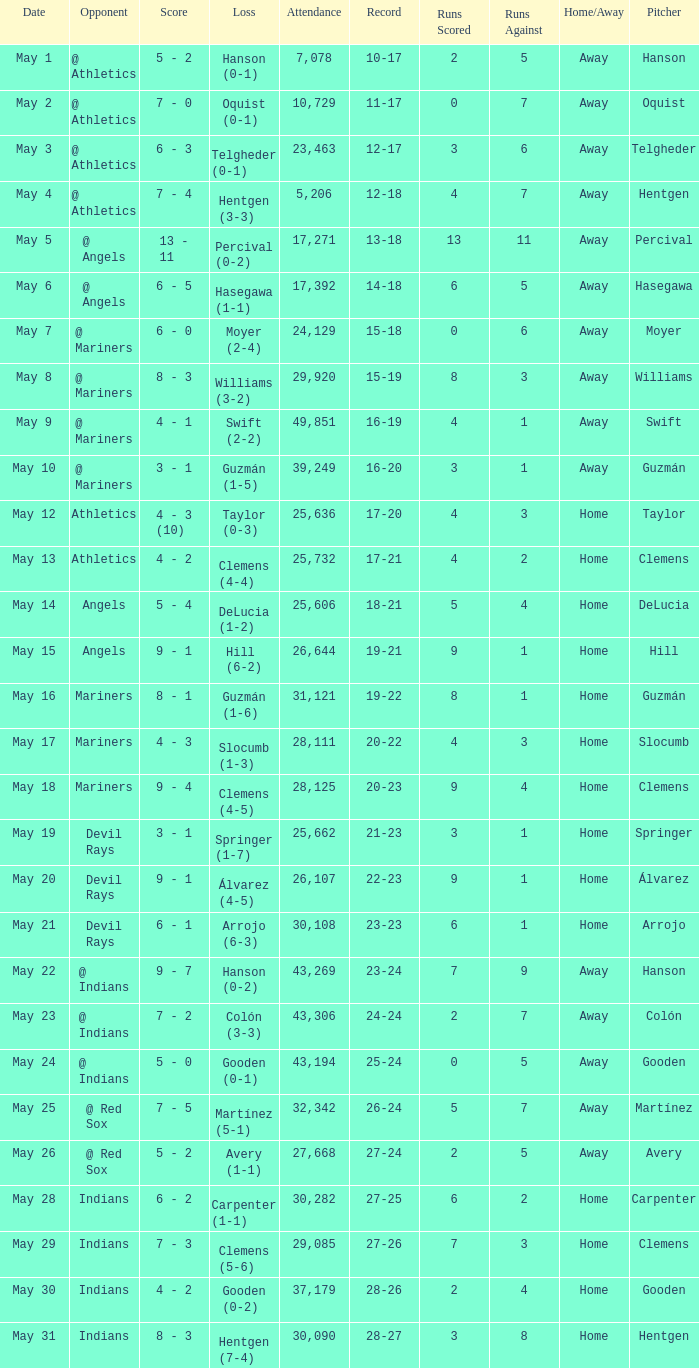Write the full table. {'header': ['Date', 'Opponent', 'Score', 'Loss', 'Attendance', 'Record', 'Runs Scored', 'Runs Against', 'Home/Away', 'Pitcher'], 'rows': [['May 1', '@ Athletics', '5 - 2', 'Hanson (0-1)', '7,078', '10-17', '2', '5', 'Away', 'Hanson'], ['May 2', '@ Athletics', '7 - 0', 'Oquist (0-1)', '10,729', '11-17', '0', '7', 'Away', 'Oquist'], ['May 3', '@ Athletics', '6 - 3', 'Telgheder (0-1)', '23,463', '12-17', '3', '6', 'Away', 'Telgheder'], ['May 4', '@ Athletics', '7 - 4', 'Hentgen (3-3)', '5,206', '12-18', '4', '7', 'Away', 'Hentgen'], ['May 5', '@ Angels', '13 - 11', 'Percival (0-2)', '17,271', '13-18', '13', '11', 'Away', 'Percival'], ['May 6', '@ Angels', '6 - 5', 'Hasegawa (1-1)', '17,392', '14-18', '6', '5', 'Away', 'Hasegawa'], ['May 7', '@ Mariners', '6 - 0', 'Moyer (2-4)', '24,129', '15-18', '0', '6', 'Away', 'Moyer'], ['May 8', '@ Mariners', '8 - 3', 'Williams (3-2)', '29,920', '15-19', '8', '3', 'Away', 'Williams'], ['May 9', '@ Mariners', '4 - 1', 'Swift (2-2)', '49,851', '16-19', '4', '1', 'Away', 'Swift'], ['May 10', '@ Mariners', '3 - 1', 'Guzmán (1-5)', '39,249', '16-20', '3', '1', 'Away', 'Guzmán'], ['May 12', 'Athletics', '4 - 3 (10)', 'Taylor (0-3)', '25,636', '17-20', '4', '3', 'Home', 'Taylor'], ['May 13', 'Athletics', '4 - 2', 'Clemens (4-4)', '25,732', '17-21', '4', '2', 'Home', 'Clemens'], ['May 14', 'Angels', '5 - 4', 'DeLucia (1-2)', '25,606', '18-21', '5', '4', 'Home', 'DeLucia'], ['May 15', 'Angels', '9 - 1', 'Hill (6-2)', '26,644', '19-21', '9', '1', 'Home', 'Hill'], ['May 16', 'Mariners', '8 - 1', 'Guzmán (1-6)', '31,121', '19-22', '8', '1', 'Home', 'Guzmán'], ['May 17', 'Mariners', '4 - 3', 'Slocumb (1-3)', '28,111', '20-22', '4', '3', 'Home', 'Slocumb'], ['May 18', 'Mariners', '9 - 4', 'Clemens (4-5)', '28,125', '20-23', '9', '4', 'Home', 'Clemens'], ['May 19', 'Devil Rays', '3 - 1', 'Springer (1-7)', '25,662', '21-23', '3', '1', 'Home', 'Springer'], ['May 20', 'Devil Rays', '9 - 1', 'Álvarez (4-5)', '26,107', '22-23', '9', '1', 'Home', 'Álvarez'], ['May 21', 'Devil Rays', '6 - 1', 'Arrojo (6-3)', '30,108', '23-23', '6', '1', 'Home', 'Arrojo'], ['May 22', '@ Indians', '9 - 7', 'Hanson (0-2)', '43,269', '23-24', '7', '9', 'Away', 'Hanson'], ['May 23', '@ Indians', '7 - 2', 'Colón (3-3)', '43,306', '24-24', '2', '7', 'Away', 'Colón'], ['May 24', '@ Indians', '5 - 0', 'Gooden (0-1)', '43,194', '25-24', '0', '5', 'Away', 'Gooden'], ['May 25', '@ Red Sox', '7 - 5', 'Martínez (5-1)', '32,342', '26-24', '5', '7', 'Away', 'Martínez'], ['May 26', '@ Red Sox', '5 - 2', 'Avery (1-1)', '27,668', '27-24', '2', '5', 'Away', 'Avery'], ['May 28', 'Indians', '6 - 2', 'Carpenter (1-1)', '30,282', '27-25', '6', '2', 'Home', 'Carpenter'], ['May 29', 'Indians', '7 - 3', 'Clemens (5-6)', '29,085', '27-26', '7', '3', 'Home', 'Clemens'], ['May 30', 'Indians', '4 - 2', 'Gooden (0-2)', '37,179', '28-26', '2', '4', 'Home', 'Gooden'], ['May 31', 'Indians', '8 - 3', 'Hentgen (7-4)', '30,090', '28-27', '3', '8', 'Home', 'Hentgen']]} For record 25-24, what is the sum of attendance? 1.0. 